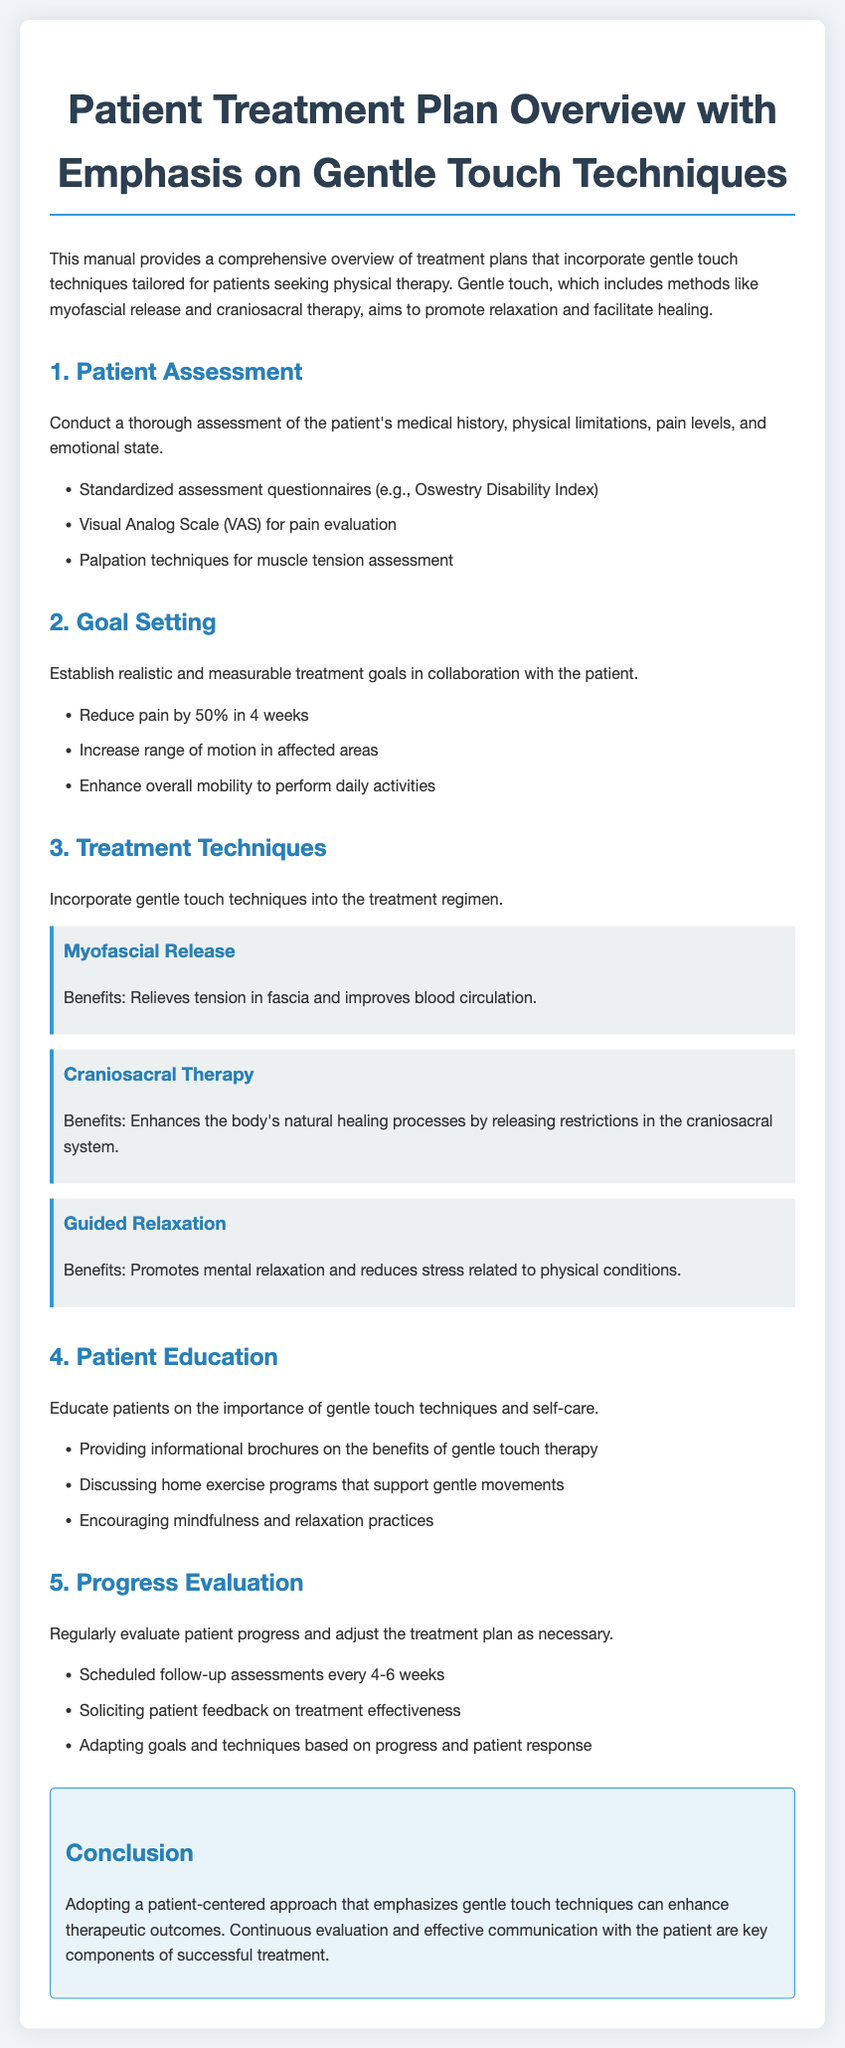What is the title of the manual? The title is explicitly mentioned at the top of the document, emphasizing the focus on patient treatment plans and gentle touch techniques.
Answer: Patient Treatment Plan Overview with Emphasis on Gentle Touch Techniques What is a technique mentioned for patient treatment? The document lists several techniques used in the treatment, specifically highlighting gentle touch methods.
Answer: Myofascial Release What is the goal related to pain reduction in weeks? A specific, measurable goal is outlined in the document regarding pain reduction for patients.
Answer: 4 weeks What assessment tool is mentioned for evaluating pain levels? The document specifies one type of tool used to gauge patient pain levels during assessments.
Answer: Visual Analog Scale What is one benefit of Craniosacral Therapy? The document describes several benefits of treatments, explicitly stating advantages of certain techniques.
Answer: Enhances the body's natural healing processes How often should follow-up assessments be conducted? The document specifies a frequency for reassessing patient progress, ensuring that adjustments can be made as needed.
Answer: Every 4-6 weeks What should be included in patient education? The manual outlines various aspects that are to be included when educating patients on their treatment.
Answer: Informational brochures What is the focus of the treatment plan? The document emphasizes an approach to patient care that centers on a specific technique integration.
Answer: Gentle touch techniques What is the main approach recommended in the conclusion? The conclusion summarizes the overall suggestion made throughout the manual regarding patient treatment planning.
Answer: Patient-centered approach 